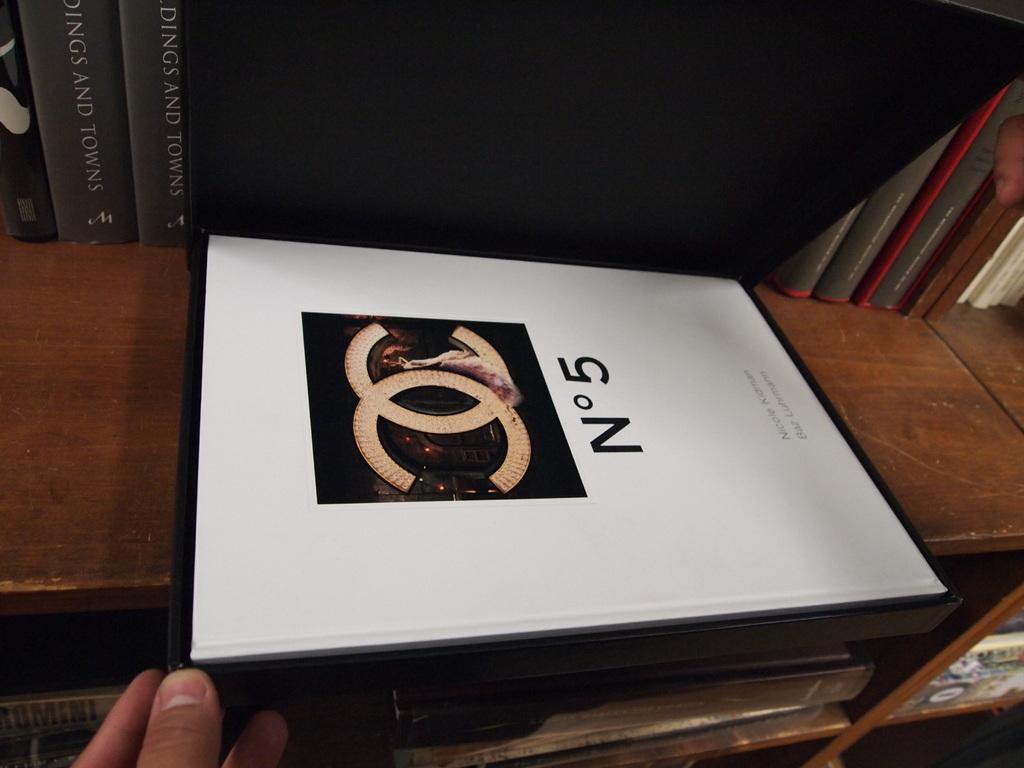What number is this?
Your answer should be compact. 5. 